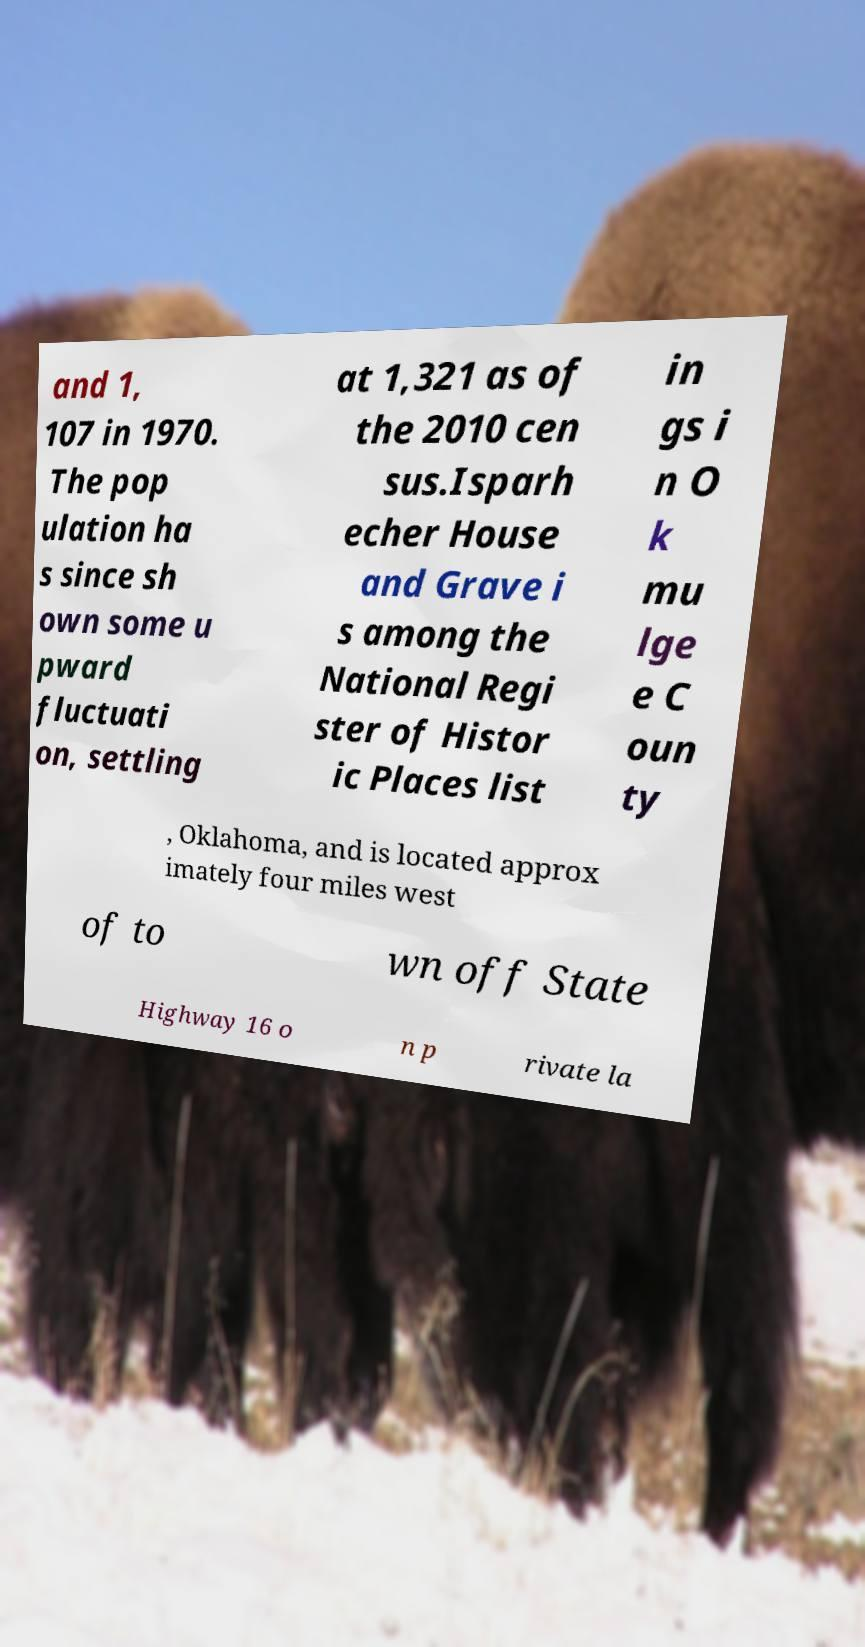Could you extract and type out the text from this image? and 1, 107 in 1970. The pop ulation ha s since sh own some u pward fluctuati on, settling at 1,321 as of the 2010 cen sus.Isparh echer House and Grave i s among the National Regi ster of Histor ic Places list in gs i n O k mu lge e C oun ty , Oklahoma, and is located approx imately four miles west of to wn off State Highway 16 o n p rivate la 